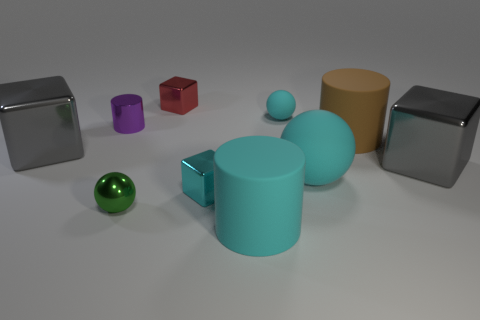Subtract 1 spheres. How many spheres are left? 2 Subtract all cyan blocks. How many blocks are left? 3 Subtract all green cubes. Subtract all gray cylinders. How many cubes are left? 4 Subtract all cylinders. How many objects are left? 7 Add 5 purple shiny cylinders. How many purple shiny cylinders exist? 6 Subtract 0 brown blocks. How many objects are left? 10 Subtract all big cubes. Subtract all gray metallic cubes. How many objects are left? 6 Add 7 large gray blocks. How many large gray blocks are left? 9 